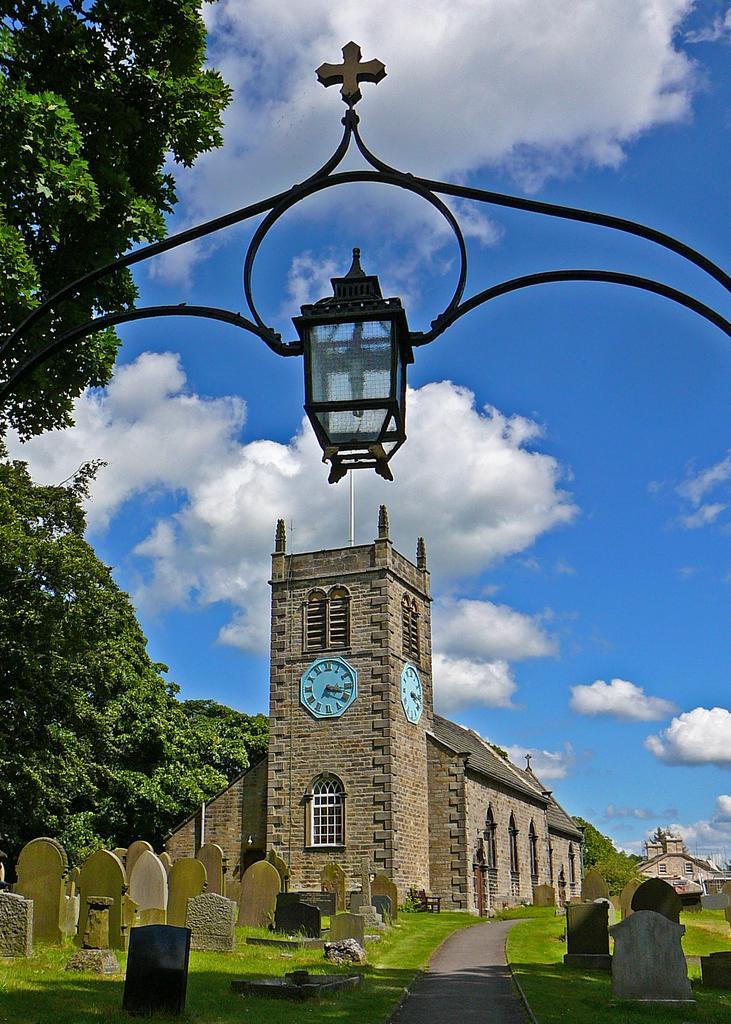Please provide a concise description of this image. In the image I can see some cemeteries and a house to which there are two clocks, windows and also I can see a lamp and some trees. 